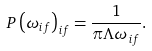Convert formula to latex. <formula><loc_0><loc_0><loc_500><loc_500>P \left ( \omega _ { i f } \right ) _ { i f } = \frac { 1 } { \pi \Lambda \omega _ { i f } } .</formula> 